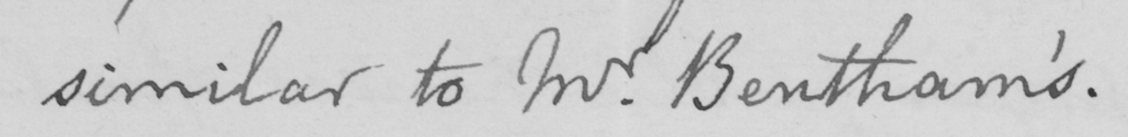Please transcribe the handwritten text in this image. similar to Mr . Bentham ' s . 